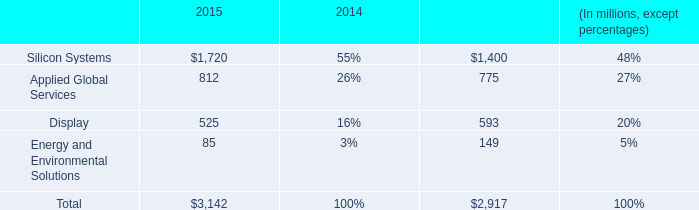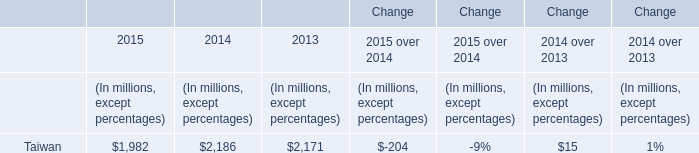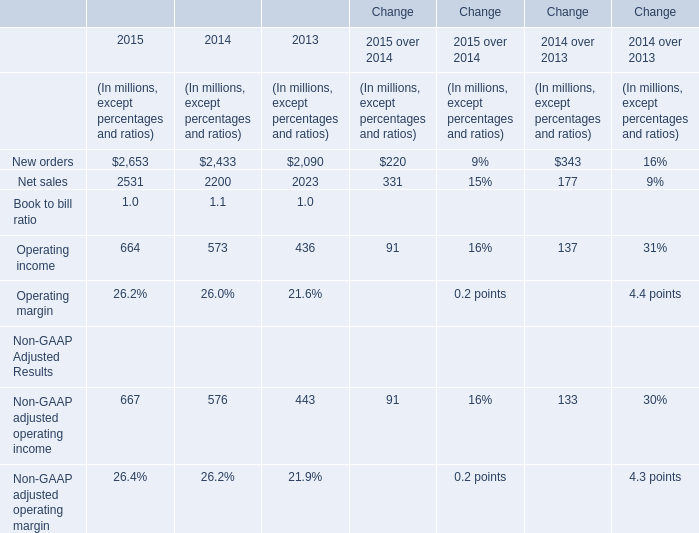What's the average of Net sales and Operating income and Non-GAAP adjusted operating income in 2015? (in million) 
Computations: (((2531 + 664) + 667) / 3)
Answer: 1287.33333. 